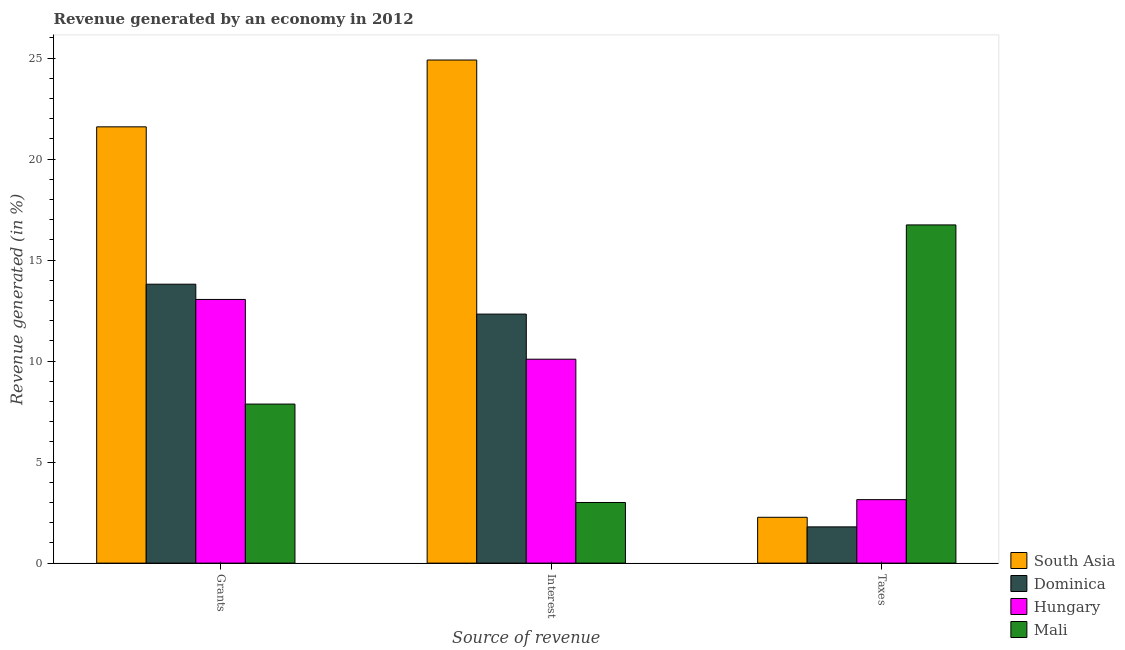How many groups of bars are there?
Your answer should be very brief. 3. Are the number of bars per tick equal to the number of legend labels?
Your answer should be very brief. Yes. How many bars are there on the 1st tick from the left?
Give a very brief answer. 4. How many bars are there on the 1st tick from the right?
Your answer should be very brief. 4. What is the label of the 1st group of bars from the left?
Ensure brevity in your answer.  Grants. What is the percentage of revenue generated by interest in Mali?
Give a very brief answer. 3. Across all countries, what is the maximum percentage of revenue generated by interest?
Provide a succinct answer. 24.91. Across all countries, what is the minimum percentage of revenue generated by taxes?
Your answer should be very brief. 1.79. In which country was the percentage of revenue generated by taxes maximum?
Give a very brief answer. Mali. In which country was the percentage of revenue generated by interest minimum?
Provide a short and direct response. Mali. What is the total percentage of revenue generated by taxes in the graph?
Provide a succinct answer. 23.95. What is the difference between the percentage of revenue generated by grants in South Asia and that in Dominica?
Give a very brief answer. 7.79. What is the difference between the percentage of revenue generated by taxes in Hungary and the percentage of revenue generated by interest in Dominica?
Ensure brevity in your answer.  -9.19. What is the average percentage of revenue generated by grants per country?
Offer a very short reply. 14.09. What is the difference between the percentage of revenue generated by taxes and percentage of revenue generated by interest in Mali?
Offer a terse response. 13.74. In how many countries, is the percentage of revenue generated by grants greater than 17 %?
Ensure brevity in your answer.  1. What is the ratio of the percentage of revenue generated by grants in Mali to that in Dominica?
Offer a terse response. 0.57. Is the difference between the percentage of revenue generated by interest in South Asia and Mali greater than the difference between the percentage of revenue generated by taxes in South Asia and Mali?
Offer a terse response. Yes. What is the difference between the highest and the second highest percentage of revenue generated by grants?
Make the answer very short. 7.79. What is the difference between the highest and the lowest percentage of revenue generated by grants?
Provide a succinct answer. 13.73. Is the sum of the percentage of revenue generated by interest in Dominica and Mali greater than the maximum percentage of revenue generated by taxes across all countries?
Make the answer very short. No. What does the 4th bar from the right in Interest represents?
Provide a short and direct response. South Asia. Is it the case that in every country, the sum of the percentage of revenue generated by grants and percentage of revenue generated by interest is greater than the percentage of revenue generated by taxes?
Offer a very short reply. No. How many bars are there?
Provide a succinct answer. 12. How many countries are there in the graph?
Your answer should be very brief. 4. Are the values on the major ticks of Y-axis written in scientific E-notation?
Your response must be concise. No. How are the legend labels stacked?
Your answer should be very brief. Vertical. What is the title of the graph?
Provide a succinct answer. Revenue generated by an economy in 2012. What is the label or title of the X-axis?
Give a very brief answer. Source of revenue. What is the label or title of the Y-axis?
Keep it short and to the point. Revenue generated (in %). What is the Revenue generated (in %) of South Asia in Grants?
Provide a succinct answer. 21.6. What is the Revenue generated (in %) of Dominica in Grants?
Your answer should be very brief. 13.81. What is the Revenue generated (in %) in Hungary in Grants?
Ensure brevity in your answer.  13.05. What is the Revenue generated (in %) of Mali in Grants?
Provide a succinct answer. 7.87. What is the Revenue generated (in %) in South Asia in Interest?
Provide a short and direct response. 24.91. What is the Revenue generated (in %) in Dominica in Interest?
Make the answer very short. 12.33. What is the Revenue generated (in %) in Hungary in Interest?
Keep it short and to the point. 10.1. What is the Revenue generated (in %) in Mali in Interest?
Provide a short and direct response. 3. What is the Revenue generated (in %) of South Asia in Taxes?
Make the answer very short. 2.27. What is the Revenue generated (in %) of Dominica in Taxes?
Keep it short and to the point. 1.79. What is the Revenue generated (in %) of Hungary in Taxes?
Provide a short and direct response. 3.14. What is the Revenue generated (in %) in Mali in Taxes?
Ensure brevity in your answer.  16.74. Across all Source of revenue, what is the maximum Revenue generated (in %) in South Asia?
Your response must be concise. 24.91. Across all Source of revenue, what is the maximum Revenue generated (in %) in Dominica?
Provide a short and direct response. 13.81. Across all Source of revenue, what is the maximum Revenue generated (in %) in Hungary?
Provide a succinct answer. 13.05. Across all Source of revenue, what is the maximum Revenue generated (in %) in Mali?
Offer a very short reply. 16.74. Across all Source of revenue, what is the minimum Revenue generated (in %) in South Asia?
Provide a short and direct response. 2.27. Across all Source of revenue, what is the minimum Revenue generated (in %) of Dominica?
Your answer should be compact. 1.79. Across all Source of revenue, what is the minimum Revenue generated (in %) of Hungary?
Your response must be concise. 3.14. Across all Source of revenue, what is the minimum Revenue generated (in %) of Mali?
Make the answer very short. 3. What is the total Revenue generated (in %) of South Asia in the graph?
Provide a succinct answer. 48.78. What is the total Revenue generated (in %) of Dominica in the graph?
Provide a succinct answer. 27.93. What is the total Revenue generated (in %) of Hungary in the graph?
Your answer should be compact. 26.29. What is the total Revenue generated (in %) in Mali in the graph?
Your response must be concise. 27.62. What is the difference between the Revenue generated (in %) in South Asia in Grants and that in Interest?
Provide a short and direct response. -3.31. What is the difference between the Revenue generated (in %) in Dominica in Grants and that in Interest?
Ensure brevity in your answer.  1.48. What is the difference between the Revenue generated (in %) of Hungary in Grants and that in Interest?
Offer a very short reply. 2.96. What is the difference between the Revenue generated (in %) of Mali in Grants and that in Interest?
Provide a short and direct response. 4.87. What is the difference between the Revenue generated (in %) in South Asia in Grants and that in Taxes?
Your answer should be compact. 19.33. What is the difference between the Revenue generated (in %) of Dominica in Grants and that in Taxes?
Offer a very short reply. 12.02. What is the difference between the Revenue generated (in %) of Hungary in Grants and that in Taxes?
Offer a terse response. 9.91. What is the difference between the Revenue generated (in %) in Mali in Grants and that in Taxes?
Provide a succinct answer. -8.87. What is the difference between the Revenue generated (in %) of South Asia in Interest and that in Taxes?
Your answer should be compact. 22.64. What is the difference between the Revenue generated (in %) in Dominica in Interest and that in Taxes?
Provide a short and direct response. 10.54. What is the difference between the Revenue generated (in %) of Hungary in Interest and that in Taxes?
Ensure brevity in your answer.  6.95. What is the difference between the Revenue generated (in %) of Mali in Interest and that in Taxes?
Offer a very short reply. -13.74. What is the difference between the Revenue generated (in %) in South Asia in Grants and the Revenue generated (in %) in Dominica in Interest?
Your response must be concise. 9.27. What is the difference between the Revenue generated (in %) in South Asia in Grants and the Revenue generated (in %) in Hungary in Interest?
Your answer should be compact. 11.5. What is the difference between the Revenue generated (in %) in South Asia in Grants and the Revenue generated (in %) in Mali in Interest?
Make the answer very short. 18.6. What is the difference between the Revenue generated (in %) in Dominica in Grants and the Revenue generated (in %) in Hungary in Interest?
Make the answer very short. 3.71. What is the difference between the Revenue generated (in %) in Dominica in Grants and the Revenue generated (in %) in Mali in Interest?
Your answer should be compact. 10.81. What is the difference between the Revenue generated (in %) of Hungary in Grants and the Revenue generated (in %) of Mali in Interest?
Your response must be concise. 10.05. What is the difference between the Revenue generated (in %) of South Asia in Grants and the Revenue generated (in %) of Dominica in Taxes?
Your answer should be compact. 19.81. What is the difference between the Revenue generated (in %) of South Asia in Grants and the Revenue generated (in %) of Hungary in Taxes?
Offer a terse response. 18.46. What is the difference between the Revenue generated (in %) of South Asia in Grants and the Revenue generated (in %) of Mali in Taxes?
Offer a very short reply. 4.86. What is the difference between the Revenue generated (in %) in Dominica in Grants and the Revenue generated (in %) in Hungary in Taxes?
Offer a very short reply. 10.67. What is the difference between the Revenue generated (in %) of Dominica in Grants and the Revenue generated (in %) of Mali in Taxes?
Keep it short and to the point. -2.94. What is the difference between the Revenue generated (in %) of Hungary in Grants and the Revenue generated (in %) of Mali in Taxes?
Give a very brief answer. -3.69. What is the difference between the Revenue generated (in %) in South Asia in Interest and the Revenue generated (in %) in Dominica in Taxes?
Offer a terse response. 23.11. What is the difference between the Revenue generated (in %) in South Asia in Interest and the Revenue generated (in %) in Hungary in Taxes?
Offer a terse response. 21.77. What is the difference between the Revenue generated (in %) of South Asia in Interest and the Revenue generated (in %) of Mali in Taxes?
Your response must be concise. 8.16. What is the difference between the Revenue generated (in %) in Dominica in Interest and the Revenue generated (in %) in Hungary in Taxes?
Make the answer very short. 9.19. What is the difference between the Revenue generated (in %) of Dominica in Interest and the Revenue generated (in %) of Mali in Taxes?
Your answer should be compact. -4.42. What is the difference between the Revenue generated (in %) in Hungary in Interest and the Revenue generated (in %) in Mali in Taxes?
Your answer should be very brief. -6.65. What is the average Revenue generated (in %) in South Asia per Source of revenue?
Your response must be concise. 16.26. What is the average Revenue generated (in %) of Dominica per Source of revenue?
Offer a terse response. 9.31. What is the average Revenue generated (in %) in Hungary per Source of revenue?
Your response must be concise. 8.76. What is the average Revenue generated (in %) of Mali per Source of revenue?
Ensure brevity in your answer.  9.21. What is the difference between the Revenue generated (in %) in South Asia and Revenue generated (in %) in Dominica in Grants?
Provide a short and direct response. 7.79. What is the difference between the Revenue generated (in %) in South Asia and Revenue generated (in %) in Hungary in Grants?
Your answer should be compact. 8.55. What is the difference between the Revenue generated (in %) of South Asia and Revenue generated (in %) of Mali in Grants?
Your response must be concise. 13.73. What is the difference between the Revenue generated (in %) of Dominica and Revenue generated (in %) of Hungary in Grants?
Provide a succinct answer. 0.76. What is the difference between the Revenue generated (in %) in Dominica and Revenue generated (in %) in Mali in Grants?
Offer a terse response. 5.93. What is the difference between the Revenue generated (in %) of Hungary and Revenue generated (in %) of Mali in Grants?
Keep it short and to the point. 5.18. What is the difference between the Revenue generated (in %) in South Asia and Revenue generated (in %) in Dominica in Interest?
Keep it short and to the point. 12.58. What is the difference between the Revenue generated (in %) in South Asia and Revenue generated (in %) in Hungary in Interest?
Provide a short and direct response. 14.81. What is the difference between the Revenue generated (in %) of South Asia and Revenue generated (in %) of Mali in Interest?
Your answer should be very brief. 21.91. What is the difference between the Revenue generated (in %) of Dominica and Revenue generated (in %) of Hungary in Interest?
Give a very brief answer. 2.23. What is the difference between the Revenue generated (in %) in Dominica and Revenue generated (in %) in Mali in Interest?
Give a very brief answer. 9.33. What is the difference between the Revenue generated (in %) of Hungary and Revenue generated (in %) of Mali in Interest?
Your answer should be very brief. 7.1. What is the difference between the Revenue generated (in %) of South Asia and Revenue generated (in %) of Dominica in Taxes?
Provide a short and direct response. 0.47. What is the difference between the Revenue generated (in %) of South Asia and Revenue generated (in %) of Hungary in Taxes?
Offer a terse response. -0.87. What is the difference between the Revenue generated (in %) in South Asia and Revenue generated (in %) in Mali in Taxes?
Give a very brief answer. -14.48. What is the difference between the Revenue generated (in %) of Dominica and Revenue generated (in %) of Hungary in Taxes?
Keep it short and to the point. -1.35. What is the difference between the Revenue generated (in %) of Dominica and Revenue generated (in %) of Mali in Taxes?
Provide a succinct answer. -14.95. What is the difference between the Revenue generated (in %) of Hungary and Revenue generated (in %) of Mali in Taxes?
Your response must be concise. -13.6. What is the ratio of the Revenue generated (in %) in South Asia in Grants to that in Interest?
Give a very brief answer. 0.87. What is the ratio of the Revenue generated (in %) of Dominica in Grants to that in Interest?
Your response must be concise. 1.12. What is the ratio of the Revenue generated (in %) of Hungary in Grants to that in Interest?
Your response must be concise. 1.29. What is the ratio of the Revenue generated (in %) in Mali in Grants to that in Interest?
Your answer should be very brief. 2.62. What is the ratio of the Revenue generated (in %) in South Asia in Grants to that in Taxes?
Ensure brevity in your answer.  9.52. What is the ratio of the Revenue generated (in %) in Dominica in Grants to that in Taxes?
Provide a short and direct response. 7.7. What is the ratio of the Revenue generated (in %) in Hungary in Grants to that in Taxes?
Give a very brief answer. 4.15. What is the ratio of the Revenue generated (in %) of Mali in Grants to that in Taxes?
Your response must be concise. 0.47. What is the ratio of the Revenue generated (in %) in South Asia in Interest to that in Taxes?
Keep it short and to the point. 10.98. What is the ratio of the Revenue generated (in %) of Dominica in Interest to that in Taxes?
Keep it short and to the point. 6.87. What is the ratio of the Revenue generated (in %) of Hungary in Interest to that in Taxes?
Ensure brevity in your answer.  3.21. What is the ratio of the Revenue generated (in %) in Mali in Interest to that in Taxes?
Provide a succinct answer. 0.18. What is the difference between the highest and the second highest Revenue generated (in %) in South Asia?
Ensure brevity in your answer.  3.31. What is the difference between the highest and the second highest Revenue generated (in %) in Dominica?
Provide a short and direct response. 1.48. What is the difference between the highest and the second highest Revenue generated (in %) in Hungary?
Offer a terse response. 2.96. What is the difference between the highest and the second highest Revenue generated (in %) in Mali?
Provide a succinct answer. 8.87. What is the difference between the highest and the lowest Revenue generated (in %) of South Asia?
Offer a very short reply. 22.64. What is the difference between the highest and the lowest Revenue generated (in %) in Dominica?
Your response must be concise. 12.02. What is the difference between the highest and the lowest Revenue generated (in %) of Hungary?
Your response must be concise. 9.91. What is the difference between the highest and the lowest Revenue generated (in %) of Mali?
Provide a short and direct response. 13.74. 